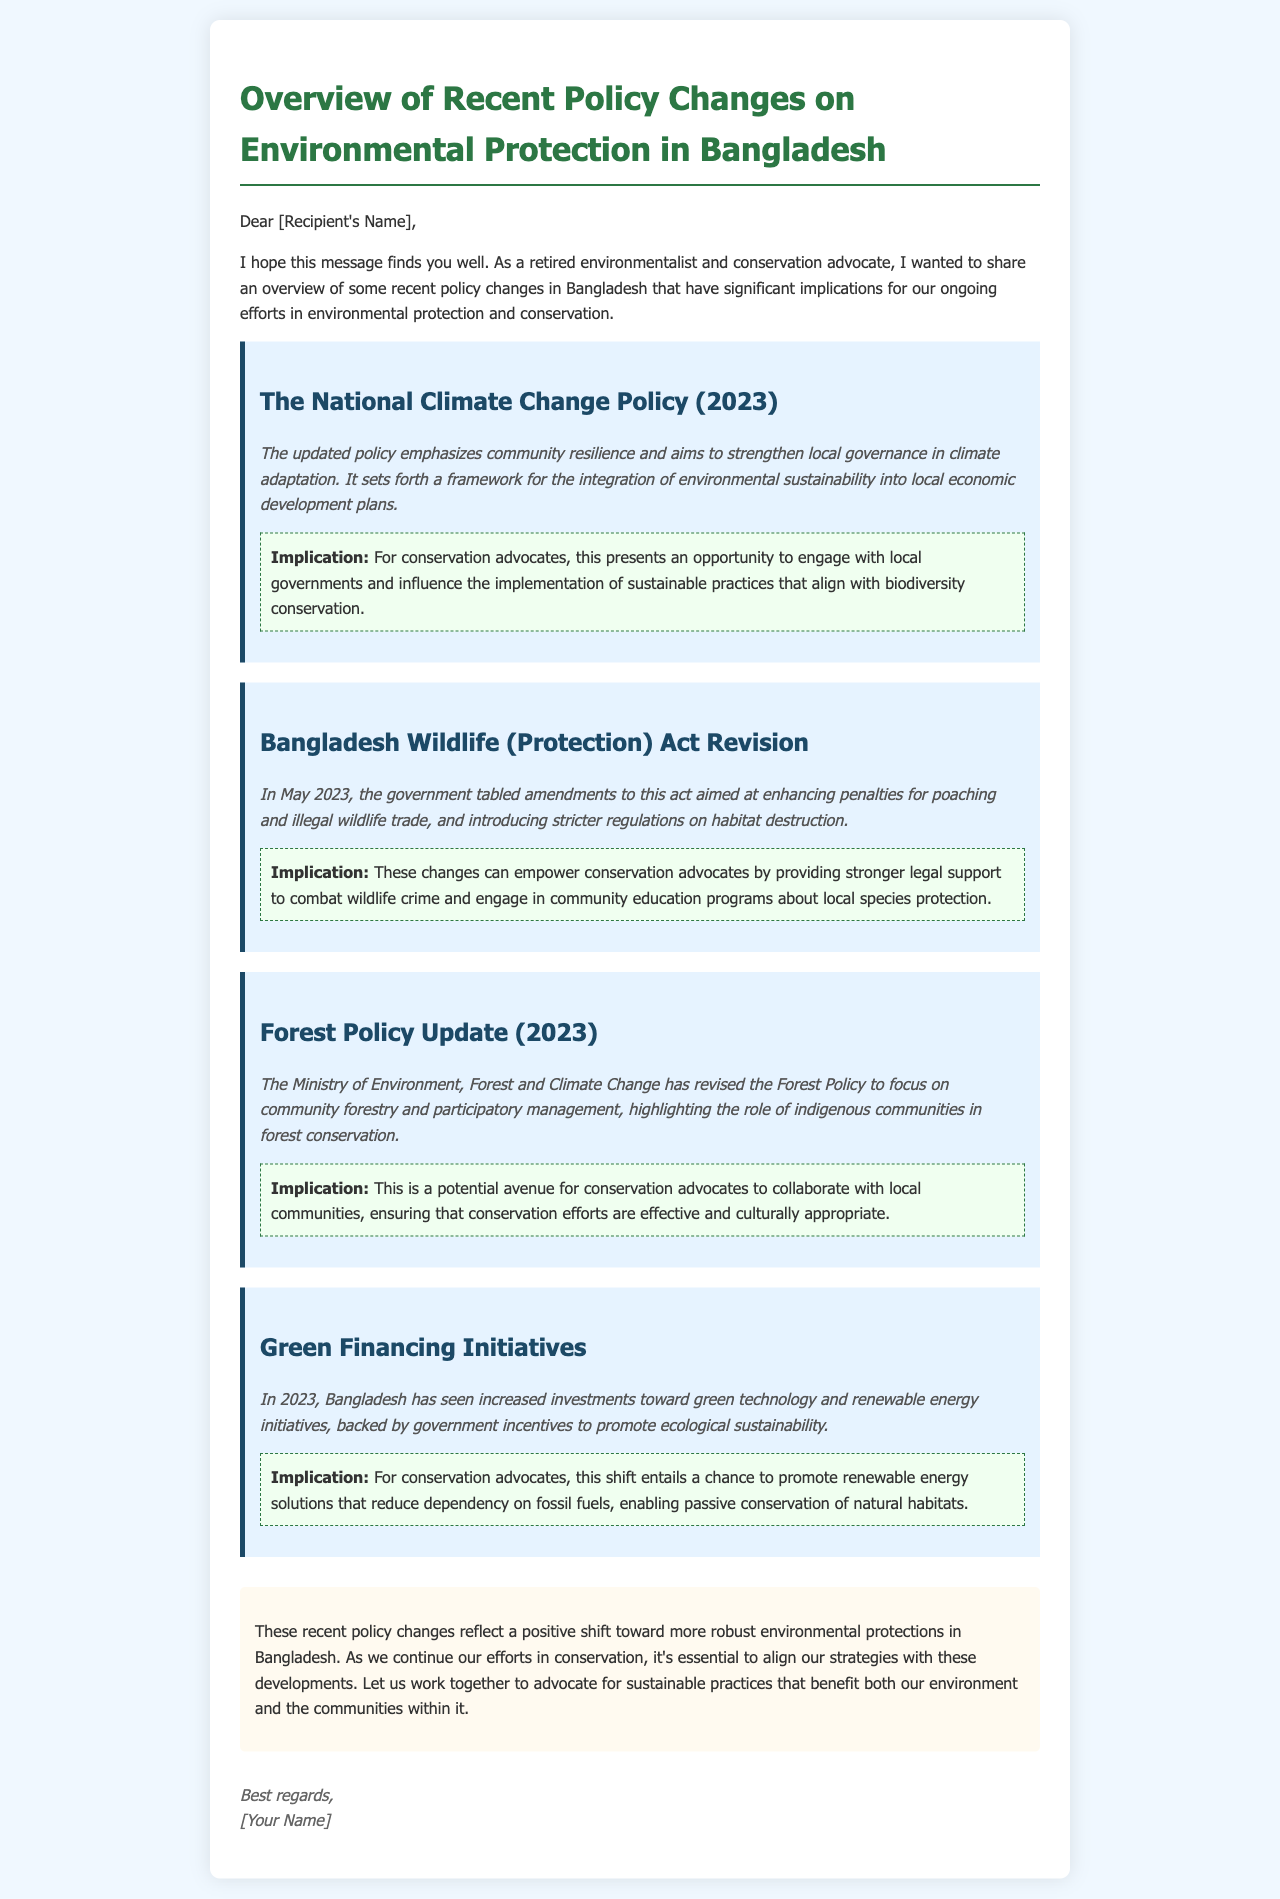What is the title of the email? The title of the email is prominently displayed at the top of the document.
Answer: Overview of Recent Policy Changes on Environmental Protection in Bangladesh When was the Bangladesh Wildlife (Protection) Act revised? The document mentions the date when the revisions were tabled.
Answer: May 2023 What is a key focus of the National Climate Change Policy (2023)? The document outlines the main emphasis of the updated policy.
Answer: Community resilience What type of initiatives have increased investment in 2023? The document specifies the nature of the initiatives receiving more funding.
Answer: Green technology What role do indigenous communities have in the revised Forest Policy? The document describes the contribution of indigenous communities to conservation efforts.
Answer: Forest conservation How do the wildlife act revisions empower conservation advocates? The document explains how the changes support conservationists in specific actions.
Answer: Stronger legal support What can conservation advocates promote due to the green financing initiatives? The document suggests an opportunity for advocates related to energy solutions.
Answer: Renewable energy solutions What is the tone of the conclusion regarding environmental protections? The conclusion reflects the author's view on the recent policy changes.
Answer: Positive shift 